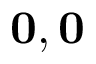<formula> <loc_0><loc_0><loc_500><loc_500>\mathbf 0 , \mathbf 0</formula> 